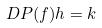<formula> <loc_0><loc_0><loc_500><loc_500>D P ( f ) h = k</formula> 